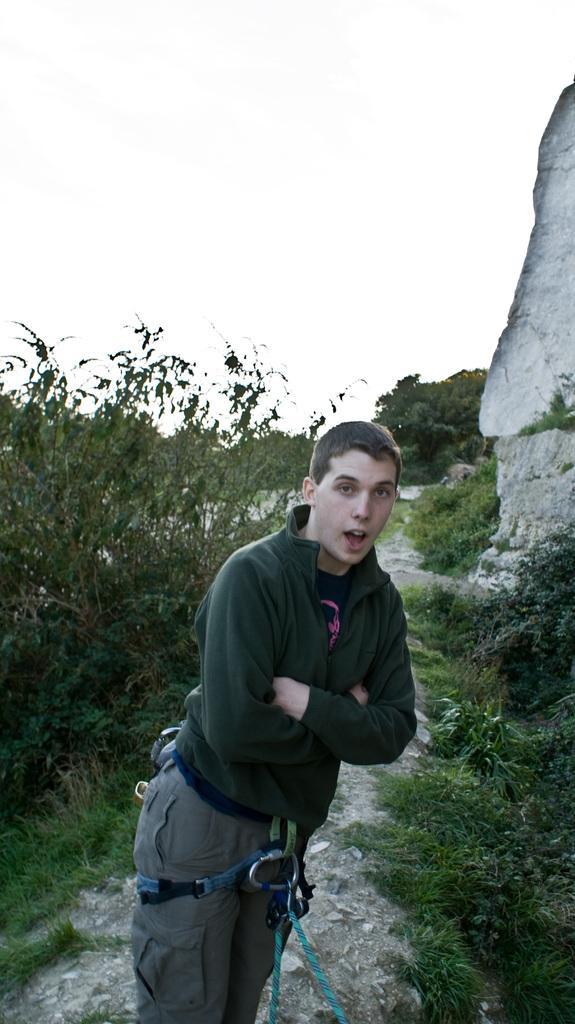Describe this image in one or two sentences. This picture is taken from outside of the city. In this image, in the middle, we can see a man standing on the land. On the right side, we can see some rocks, trees and plants. On the left side, we can also see some trees and plants. In the background, we can also see some trees and plants. At the top, we can see a sky, at the bottom, we can see some grass and a land with some stones. 